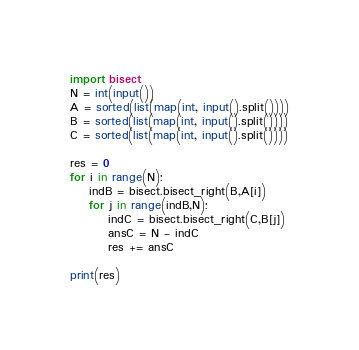Convert code to text. <code><loc_0><loc_0><loc_500><loc_500><_Python_>import bisect
N = int(input())
A = sorted(list(map(int, input().split())))
B = sorted(list(map(int, input().split())))
C = sorted(list(map(int, input().split())))

res = 0
for i in range(N):
	indB = bisect.bisect_right(B,A[i])
	for j in range(indB,N):
		indC = bisect.bisect_right(C,B[j])
		ansC = N - indC
		res += ansC

print(res)</code> 